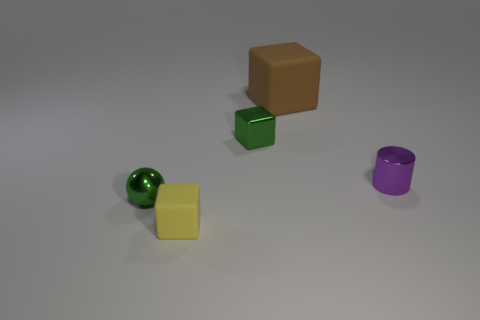Are there any other things that are the same size as the brown matte cube?
Offer a terse response. No. What material is the small green object that is in front of the small green object behind the small metallic cylinder made of?
Provide a short and direct response. Metal. What is the shape of the purple metal thing?
Provide a short and direct response. Cylinder. There is a block that is the same color as the small metal sphere; what is its size?
Offer a terse response. Small. Does the small purple thing in front of the green block have the same material as the tiny green cube?
Provide a short and direct response. Yes. Is there a thing of the same color as the metallic ball?
Ensure brevity in your answer.  Yes. There is a metallic object that is to the left of the yellow cube; is it the same shape as the small green object behind the tiny purple cylinder?
Provide a short and direct response. No. Are there any small cubes that have the same material as the small purple cylinder?
Your answer should be compact. Yes. How many yellow things are big blocks or tiny rubber blocks?
Ensure brevity in your answer.  1. What is the size of the thing that is both on the right side of the tiny green shiny block and left of the cylinder?
Provide a short and direct response. Large. 